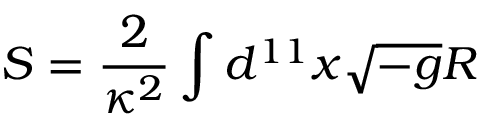Convert formula to latex. <formula><loc_0><loc_0><loc_500><loc_500>S = \frac { 2 } { \kappa ^ { 2 } } \int d ^ { 1 1 } x \sqrt { - g } R</formula> 